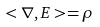Convert formula to latex. <formula><loc_0><loc_0><loc_500><loc_500>< \nabla , E > = \rho</formula> 